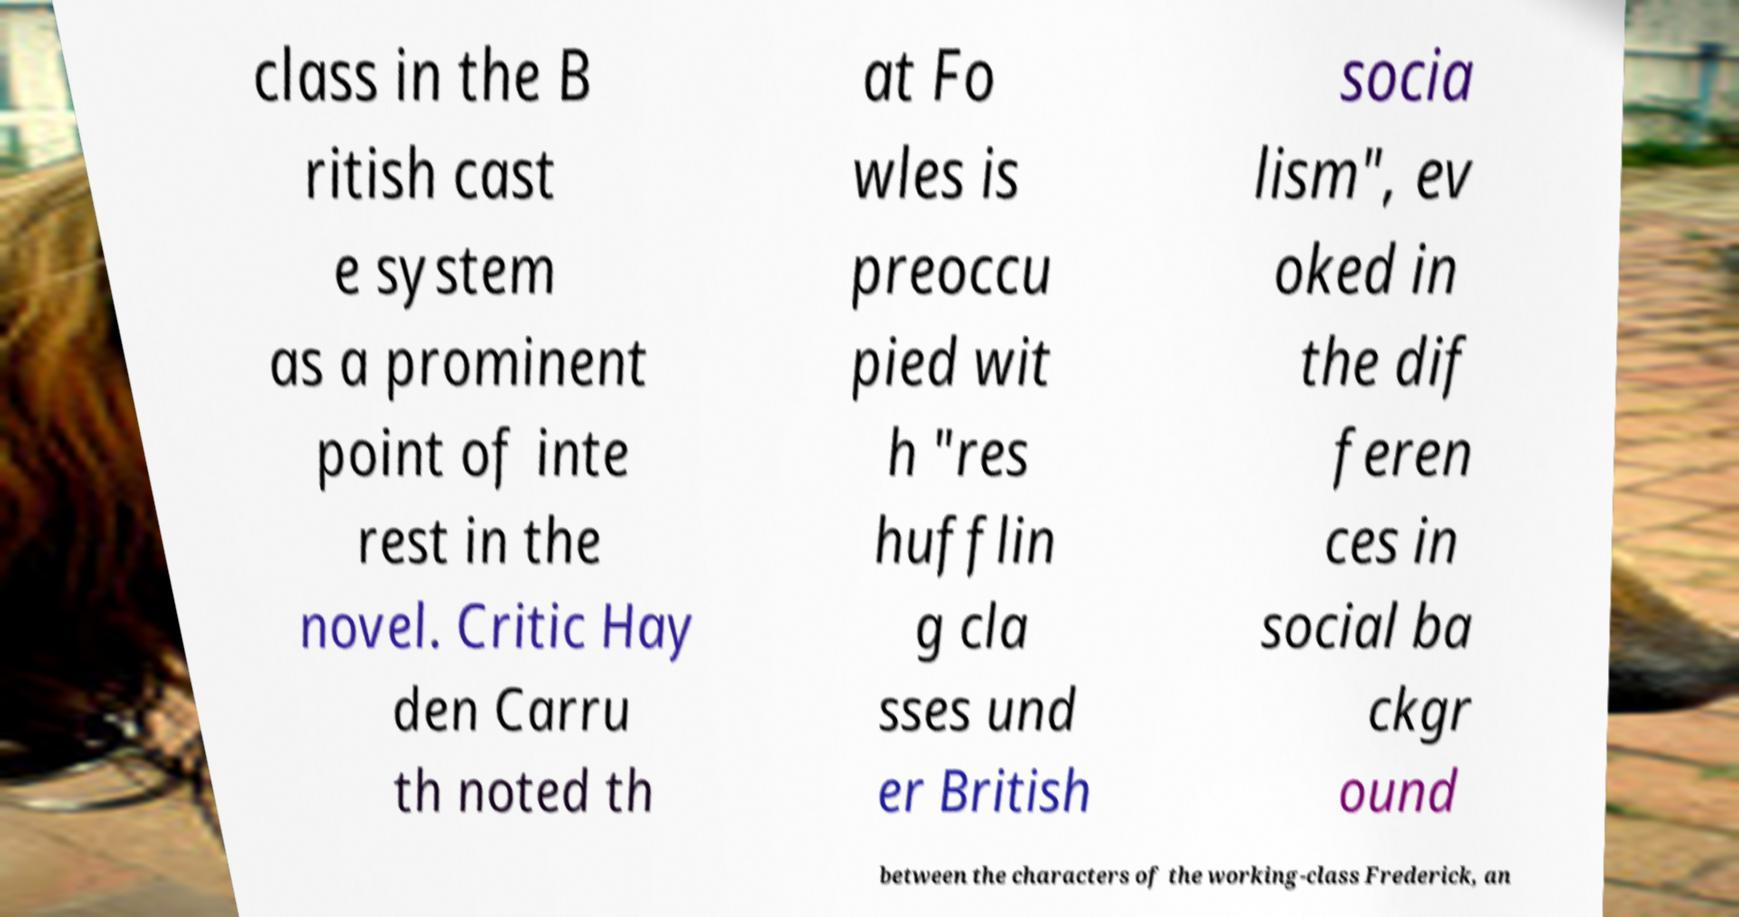Could you assist in decoding the text presented in this image and type it out clearly? class in the B ritish cast e system as a prominent point of inte rest in the novel. Critic Hay den Carru th noted th at Fo wles is preoccu pied wit h "res hufflin g cla sses und er British socia lism", ev oked in the dif feren ces in social ba ckgr ound between the characters of the working-class Frederick, an 